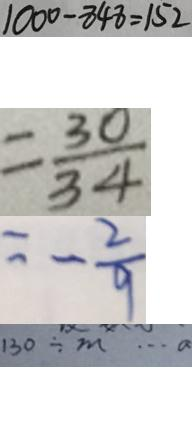Convert formula to latex. <formula><loc_0><loc_0><loc_500><loc_500>1 0 0 0 - 8 4 8 = 1 5 2 
 = \frac { 3 0 } { 3 4 } 
 = - \frac { 2 } { 9 } 
 1 3 0 \div m \cdots a</formula> 